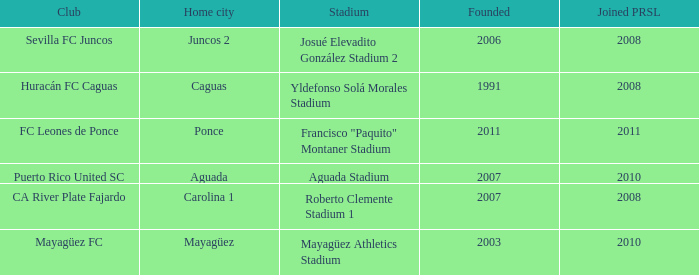What is the club that was founded before 2007, joined prsl in 2008 and the stadium is yldefonso solá morales stadium? Huracán FC Caguas. 